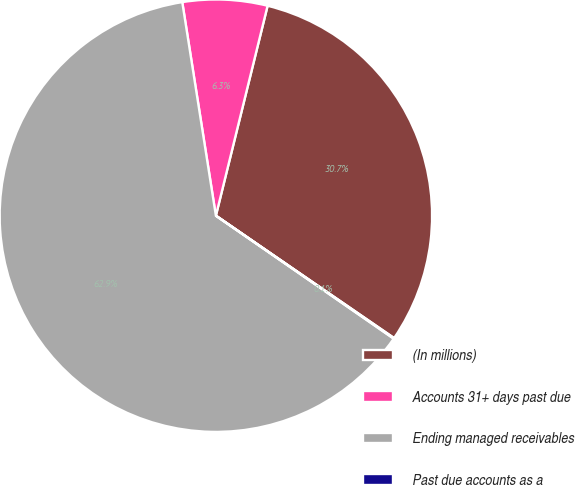Convert chart. <chart><loc_0><loc_0><loc_500><loc_500><pie_chart><fcel>(In millions)<fcel>Accounts 31+ days past due<fcel>Ending managed receivables<fcel>Past due accounts as a<nl><fcel>30.73%<fcel>6.33%<fcel>62.88%<fcel>0.05%<nl></chart> 